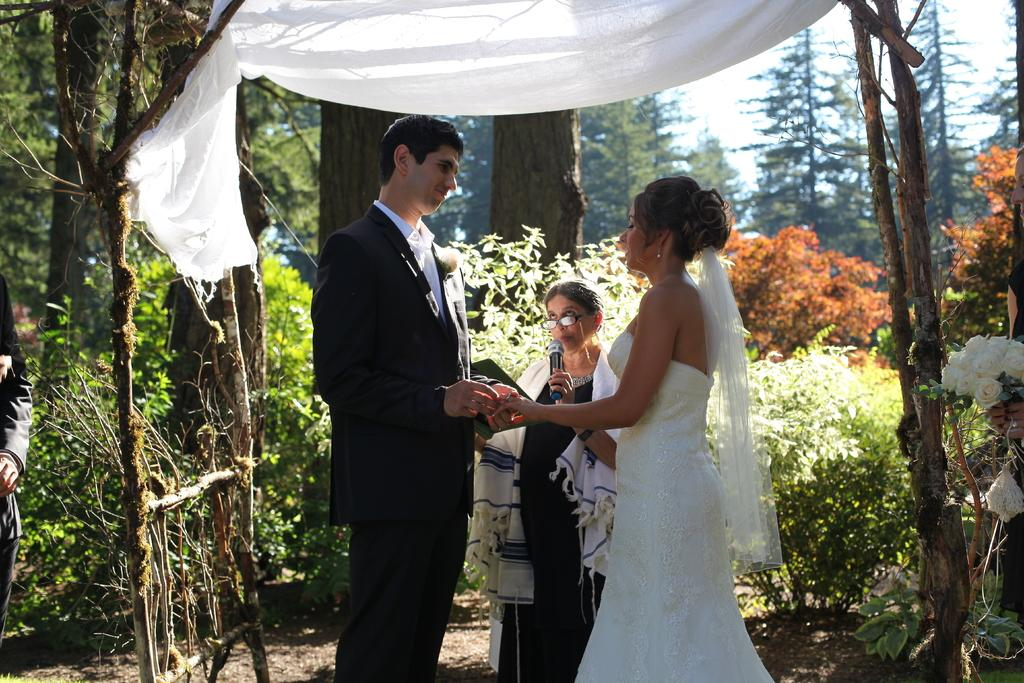What is the main feature of the image? There are many trees in the image. Can you describe the interaction between the people in the image? A person is holding a lady's hand. What is the old lady doing in the image? The old lady is standing and holding a microphone. What is the old lady's action while holding the microphone? The old lady is speaking into the microphone. What type of cherry is being used as a prop in the image? There is no cherry present in the image. What type of treatment is being administered to the old lady in the image? There is no treatment being administered to the old lady in the image; she is simply holding a microphone and speaking. 